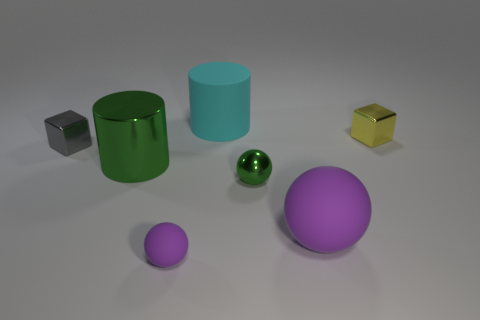Add 1 green rubber cylinders. How many objects exist? 8 Subtract all balls. How many objects are left? 4 Subtract 0 red blocks. How many objects are left? 7 Subtract all blue matte balls. Subtract all large purple things. How many objects are left? 6 Add 7 tiny green spheres. How many tiny green spheres are left? 8 Add 5 big cyan matte things. How many big cyan matte things exist? 6 